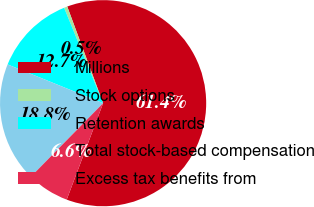<chart> <loc_0><loc_0><loc_500><loc_500><pie_chart><fcel>Millions<fcel>Stock options<fcel>Retention awards<fcel>Total stock-based compensation<fcel>Excess tax benefits from<nl><fcel>61.4%<fcel>0.52%<fcel>12.69%<fcel>18.78%<fcel>6.61%<nl></chart> 